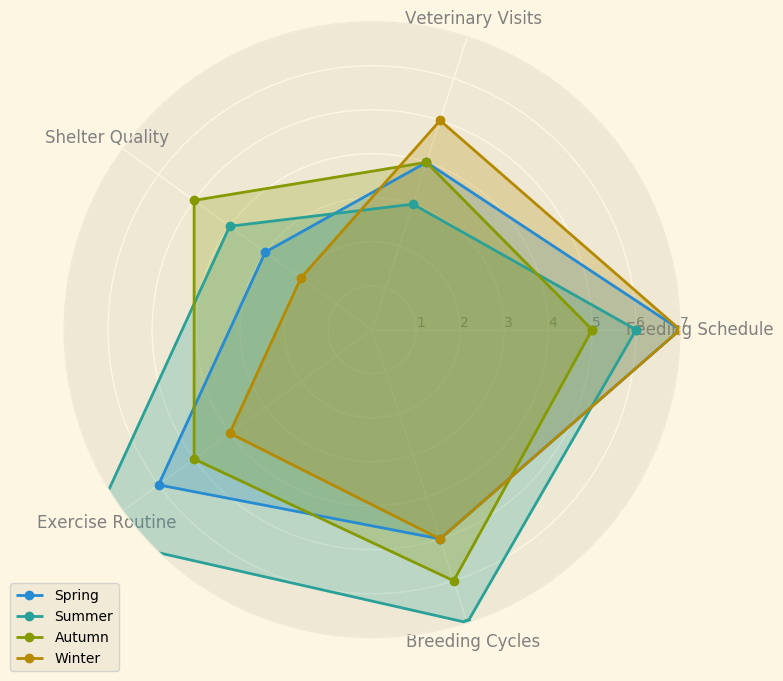What season has the highest value for the Exercise Routine category? First, look at the Exercise Routine values for all seasons on the radar chart. Spring has 6, Summer has 8, Autumn has 5, and Winter has 4. The highest value is in Summer.
Answer: Summer Which season has a higher value for Shelter Quality, Spring or Autumn? Compare the Shelter Quality values for Spring (3) and Autumn (5) on the radar chart. Autumn has a higher value.
Answer: Autumn What is the total score for Veterinary Visits across all seasons? Add the values for Veterinary Visits from each season: Spring (4) + Summer (3) + Autumn (4) + Winter (5). The total is 4 + 3 + 4 + 5 = 16.
Answer: 16 Which season has the lowest Shelter Quality? Examine the Shelter Quality values for all seasons on the radar chart. Spring has 3, Summer has 4, Autumn has 5, and Winter has 2. The lowest value is in Winter.
Answer: Winter What is the average value for Feeding Schedule in Spring and Winter? Add the Feeding Schedule values for Spring (7) and Winter (7), then divide by 2. The average is (7 + 7) / 2 = 7.
Answer: 7 In which season is the Veterinary Visits value greater than the Exercise Routine value? Compare Veterinary Visits and Exercise Routine values for all seasons: Spring (4 vs. 6), Summer (3 vs. 8), Autumn (4 vs. 5), Winter (5 vs. 4). Only in Winter the value for Veterinary Visits is greater.
Answer: Winter Which seasons have a Feeding Schedule value of 7? Identify the Feeding Schedule values for all seasons: Spring (7), Summer (6), Autumn (5), Winter (7). Spring and Winter have a value of 7.
Answer: Spring, Winter What is the difference in Breeding Cycles value between Summer and Autumn? Subtract the Breeding Cycles value for Autumn (6) from that for Summer (7). The difference is 7 - 6 = 1.
Answer: 1 